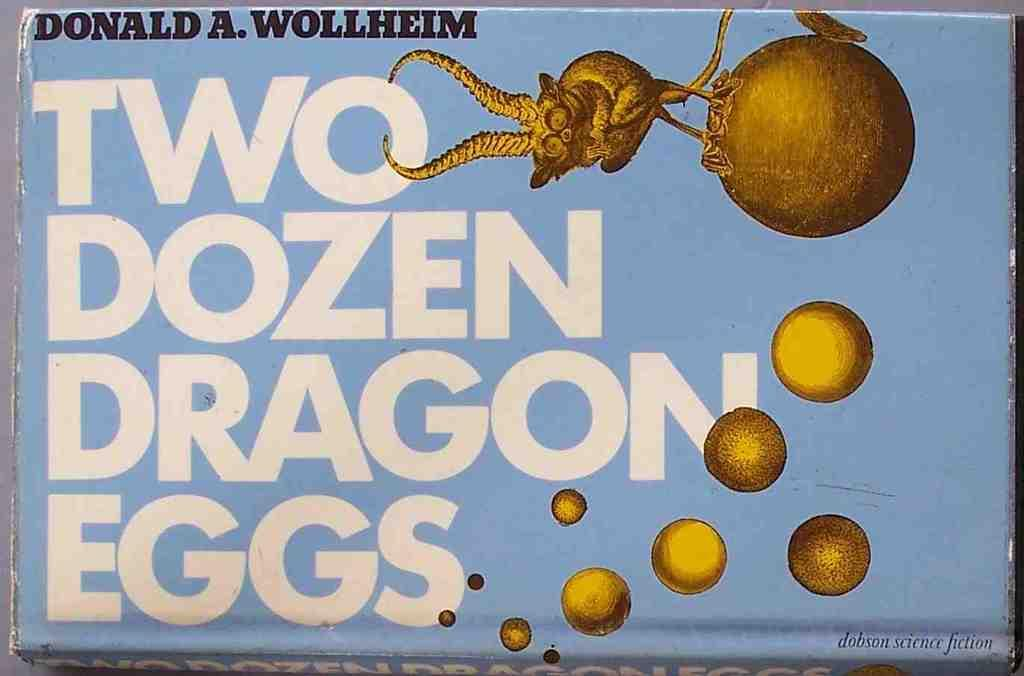What type of image is the poster in the image? The image is a poster. What can be found on the poster besides the cartoon figures? There is text on the poster. What type of characters are depicted on the poster? There are cartoon figures on the poster. Can you tell me how many boats are shown in the poster? There are no boats present in the poster; it features text and cartoon figures. What type of ear is visible on the cartoon figures in the poster? There are no ears visible on the cartoon figures in the poster, as they are likely stylized and not anatomically accurate. 